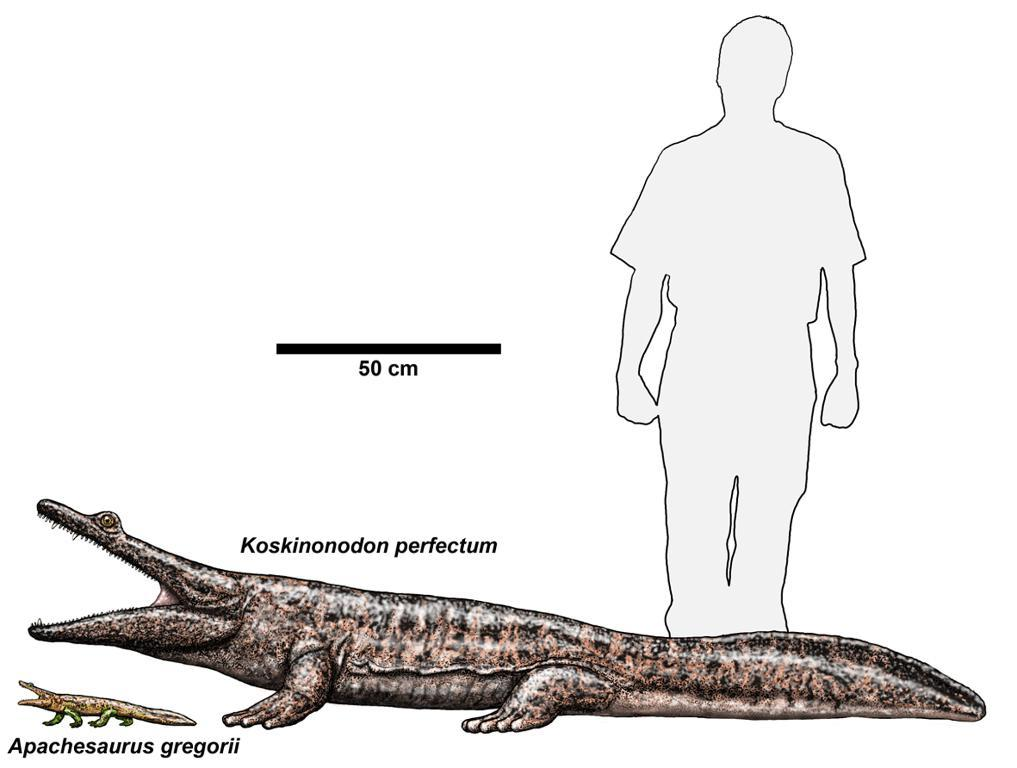What is the main subject of the paper in the image? The paper has an outline of a person and outlines of some animals. What type of text is present on the paper? There is text on the paper. What type of leather is visible on the paper in the image? There is no leather present on the paper in the image. 